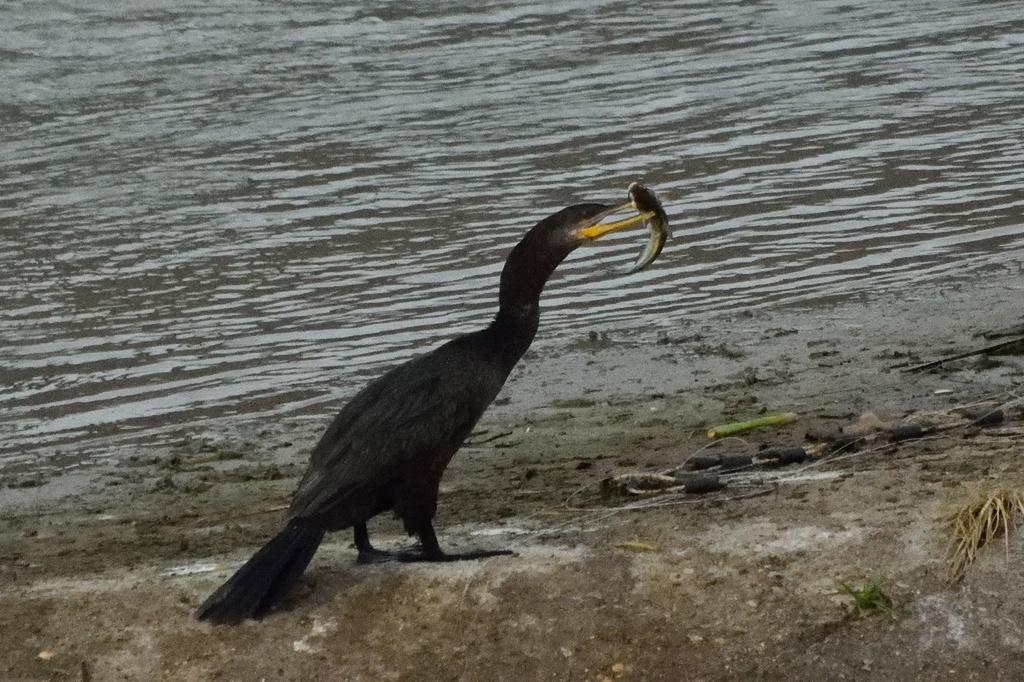What is the main subject in the center of the image? There is a bird in the center of the image. What is the bird holding in its beak? The bird is holding a fish in its beak. What can be seen in the background of the image? There is water visible in the background of the image. What is visible at the bottom of the image? The ground is visible at the bottom of the image. What type of quilt is on the bed in the image? There is no bed or quilt present in the image; it features a bird holding a fish in its beak with water and ground visible in the background. 